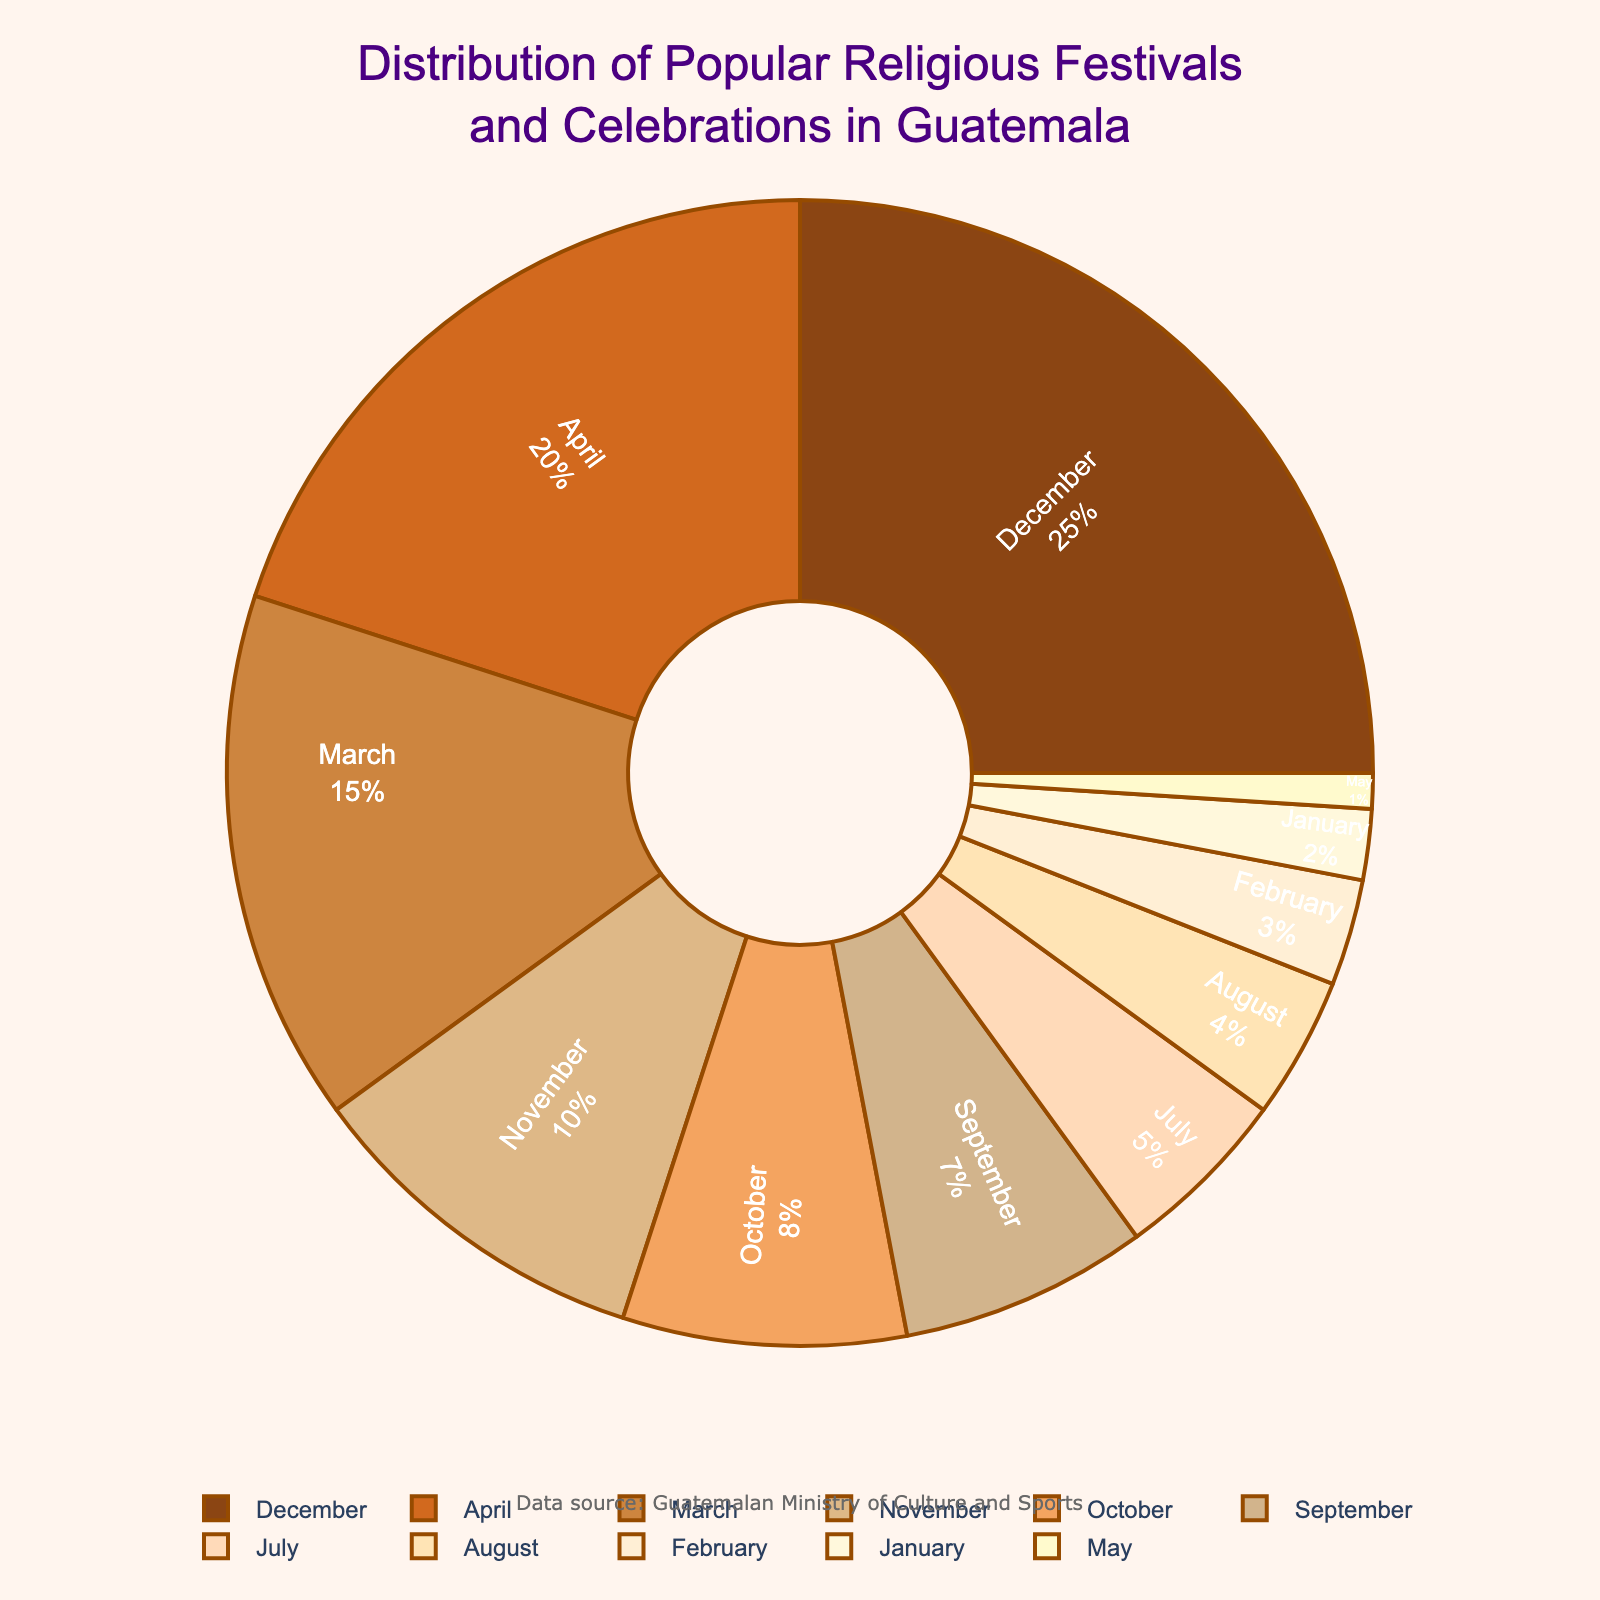Which month has the largest percentage of religious festivals and celebrations in Guatemala? The pie chart indicates the proportion of festivals and celebrations each month. By comparing the sizes, we can see December has the largest segment, making it the month with the largest percentage of religious festivals.
Answer: December What is the combined percentage of religious festivals and celebrations in Guatemala in April and March? To find the combined percentage, we sum up the percentages of April and March as shown in the pie chart, which are 20% and 15% respectively. Adding these together gives 35%.
Answer: 35% How does the percentage of religious festivals and celebrations in October compare to September? Looking at the pie chart, October has 8% while September has 7%. Simply by comparing the numbers, we can see that October has a higher percentage than September.
Answer: October Which months have the smallest percentage of religious festivals and celebrations? The smallest percentages according to the pie chart are in May and January, with May having 1% and January having 2%. These are the smallest segments in the chart.
Answer: May and January What is the total percentage of religious festivals and celebrations occurring in July, August, and February? To find the total percentage for these months, we sum the individual percentages: July (5%), August (4%), and February (3%). Adding these together gives a total of 12%.
Answer: 12% What percentage of religious festivals and celebrations occur in the first quarter of the year (January, February, March)? To determine this, we sum the percentages for January, February, and March: January (2%), February (3%), and March (15%). The total is 2% + 3% + 15% = 20%.
Answer: 20% Among July, August, and September, which month has the highest percentage of festivals and celebrations? Comparing July (5%), August (4%), and September (7%) from the pie chart, September has the highest percentage among these three months.
Answer: September What is the difference in percentage between the months with the highest and the lowest religious festivals and celebrations? The month with the highest percentage is December (25%) and the month with the lowest is May (1%). The difference is 25% - 1% = 24%.
Answer: 24% What is the percentage of religious festivals and celebrations in the last quarter of the year (October, November, December)? Summing the percentages for October (8%), November (10%), and December (25%) gives 8% + 10% + 25% = 43%.
Answer: 43% Which two consecutive months have the highest combined percentage of religious festivals and celebrations? To find the highest combined percentage for two consecutive months, we need to check each pair: January & February (5%), February & March (18%), March & April (35%), April & May (21%), May & July (6%), July & August (9%), August & September (11%), September & October (15%), October & November (18%), November & December (35%). Both March & April and November & December give the highest at 35%.
Answer: March-April and November-December 